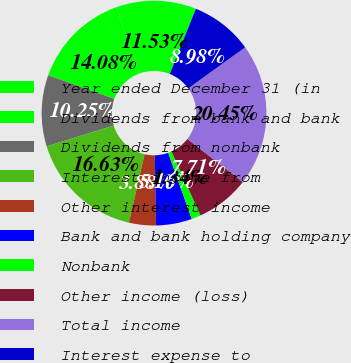<chart> <loc_0><loc_0><loc_500><loc_500><pie_chart><fcel>Year ended December 31 (in<fcel>Dividends from bank and bank<fcel>Dividends from nonbank<fcel>Interest income from<fcel>Other interest income<fcel>Bank and bank holding company<fcel>Nonbank<fcel>Other income (loss)<fcel>Total income<fcel>Interest expense to<nl><fcel>11.53%<fcel>14.08%<fcel>10.25%<fcel>16.63%<fcel>3.88%<fcel>5.16%<fcel>1.34%<fcel>7.71%<fcel>20.45%<fcel>8.98%<nl></chart> 